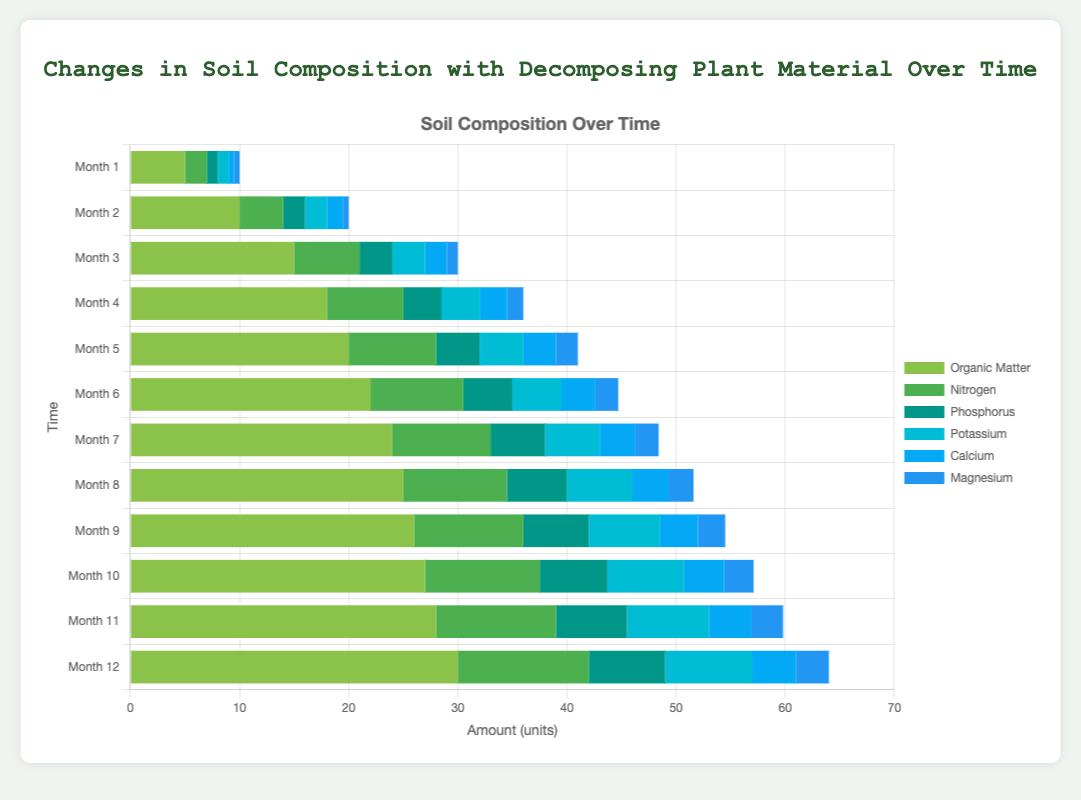What is the difference in the amount of Magnesium between Month 1 and Month 12? To find the difference, subtract the amount of Magnesium in Month 1 from the amount in Month 12. Month 12 has 3 units and Month 1 has 0.5 units, so the difference is 3 - 0.5 = 2.5
Answer: 2.5 Which month has the highest amount of Organic Matter? By examining the chart, we observe that the height of the Organic Matter component increases over time, with the highest value in Month 12 at 30 units.
Answer: Month 12 Is the amount of Nitrogen in Month 6 greater than the amount of Phosphorus in Month 12? Check the values for Nitrogen in Month 6 and Phosphorus in Month 12. Month 6 has 8.5 units of Nitrogen, and Month 12 has 7 units of Phosphorus. Since 8.5 is greater than 7, the answer is yes.
Answer: Yes Which elements reach their peak values in Month 12? By analyzing the chart, we see that all elements (Organic Matter, Nitrogen, Phosphorus, Potassium, Calcium, Magnesium) increase over time and peak in Month 12.
Answer: All elements How much total Nitrogen is added to the soil over the first three months? Sum the Nitrogen amounts for the first three months: 2 (Month 1) + 4 (Month 2) + 6 (Month 3) = 12
Answer: 12 What is the average amount of Potassium from Month 4 to Month 6? Sum the amounts of Potassium for Months 4, 5, and 6, then divide by 3. The values are 3.5, 4, and 4.5, respectively. Sum = 3.5 + 4 + 4.5 = 12. Divide by 3: 12 / 3 = 4
Answer: 4 Which element in Month 7 has the smallest amount and what is its value? In Month 7, the elements have the following values: Organic Matter (24), Nitrogen (9), Phosphorus (5), Potassium (5), Calcium (3.2), Magnesium (2.2). The smallest amount is Magnesium at 2.2.
Answer: Magnesium, 2.2 By how much does the total amount of Calcium change from Month 1 to Month 12? Subtract the amount of Calcium in Month 1 from that in Month 12. Month 1 has 0.5 units and Month 12 has 4 units. Difference is 4 - 0.5 = 3.5
Answer: 3.5 In which month does Organic Matter surpass 20 units for the first time? By examining the chart, Organic Matter surpasses 20 units in Month 6, where it reaches 22 units.
Answer: Month 6 